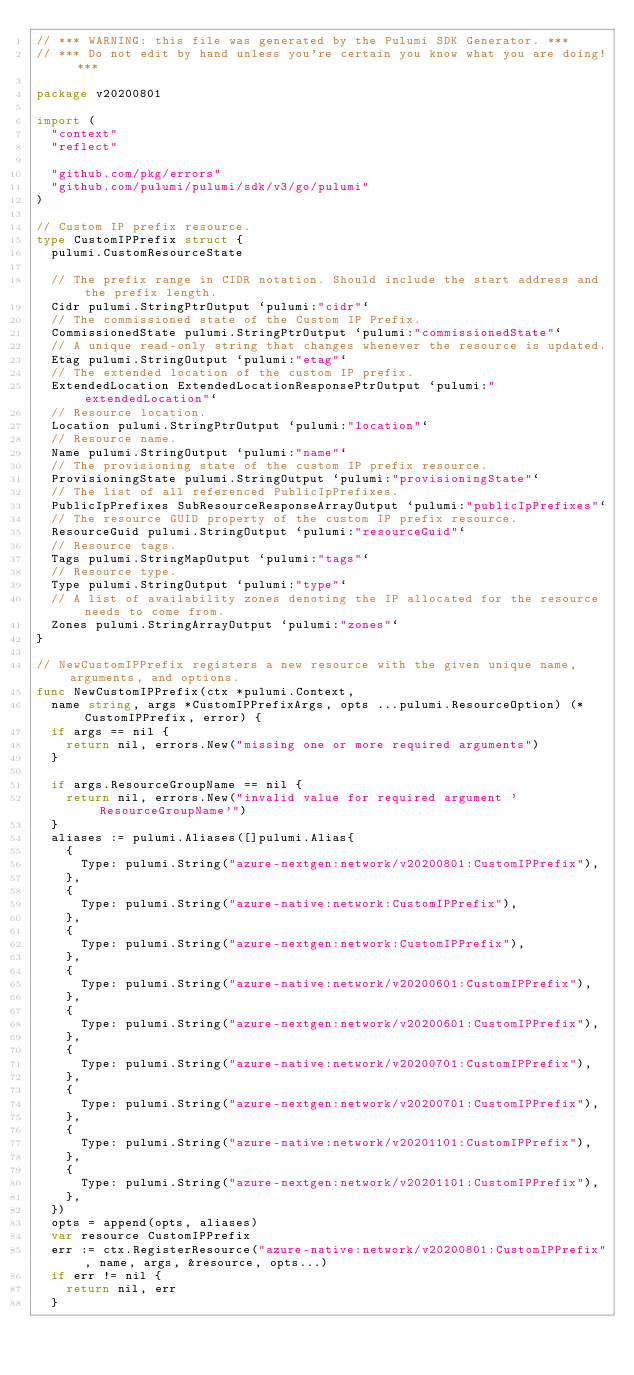<code> <loc_0><loc_0><loc_500><loc_500><_Go_>// *** WARNING: this file was generated by the Pulumi SDK Generator. ***
// *** Do not edit by hand unless you're certain you know what you are doing! ***

package v20200801

import (
	"context"
	"reflect"

	"github.com/pkg/errors"
	"github.com/pulumi/pulumi/sdk/v3/go/pulumi"
)

// Custom IP prefix resource.
type CustomIPPrefix struct {
	pulumi.CustomResourceState

	// The prefix range in CIDR notation. Should include the start address and the prefix length.
	Cidr pulumi.StringPtrOutput `pulumi:"cidr"`
	// The commissioned state of the Custom IP Prefix.
	CommissionedState pulumi.StringPtrOutput `pulumi:"commissionedState"`
	// A unique read-only string that changes whenever the resource is updated.
	Etag pulumi.StringOutput `pulumi:"etag"`
	// The extended location of the custom IP prefix.
	ExtendedLocation ExtendedLocationResponsePtrOutput `pulumi:"extendedLocation"`
	// Resource location.
	Location pulumi.StringPtrOutput `pulumi:"location"`
	// Resource name.
	Name pulumi.StringOutput `pulumi:"name"`
	// The provisioning state of the custom IP prefix resource.
	ProvisioningState pulumi.StringOutput `pulumi:"provisioningState"`
	// The list of all referenced PublicIpPrefixes.
	PublicIpPrefixes SubResourceResponseArrayOutput `pulumi:"publicIpPrefixes"`
	// The resource GUID property of the custom IP prefix resource.
	ResourceGuid pulumi.StringOutput `pulumi:"resourceGuid"`
	// Resource tags.
	Tags pulumi.StringMapOutput `pulumi:"tags"`
	// Resource type.
	Type pulumi.StringOutput `pulumi:"type"`
	// A list of availability zones denoting the IP allocated for the resource needs to come from.
	Zones pulumi.StringArrayOutput `pulumi:"zones"`
}

// NewCustomIPPrefix registers a new resource with the given unique name, arguments, and options.
func NewCustomIPPrefix(ctx *pulumi.Context,
	name string, args *CustomIPPrefixArgs, opts ...pulumi.ResourceOption) (*CustomIPPrefix, error) {
	if args == nil {
		return nil, errors.New("missing one or more required arguments")
	}

	if args.ResourceGroupName == nil {
		return nil, errors.New("invalid value for required argument 'ResourceGroupName'")
	}
	aliases := pulumi.Aliases([]pulumi.Alias{
		{
			Type: pulumi.String("azure-nextgen:network/v20200801:CustomIPPrefix"),
		},
		{
			Type: pulumi.String("azure-native:network:CustomIPPrefix"),
		},
		{
			Type: pulumi.String("azure-nextgen:network:CustomIPPrefix"),
		},
		{
			Type: pulumi.String("azure-native:network/v20200601:CustomIPPrefix"),
		},
		{
			Type: pulumi.String("azure-nextgen:network/v20200601:CustomIPPrefix"),
		},
		{
			Type: pulumi.String("azure-native:network/v20200701:CustomIPPrefix"),
		},
		{
			Type: pulumi.String("azure-nextgen:network/v20200701:CustomIPPrefix"),
		},
		{
			Type: pulumi.String("azure-native:network/v20201101:CustomIPPrefix"),
		},
		{
			Type: pulumi.String("azure-nextgen:network/v20201101:CustomIPPrefix"),
		},
	})
	opts = append(opts, aliases)
	var resource CustomIPPrefix
	err := ctx.RegisterResource("azure-native:network/v20200801:CustomIPPrefix", name, args, &resource, opts...)
	if err != nil {
		return nil, err
	}</code> 